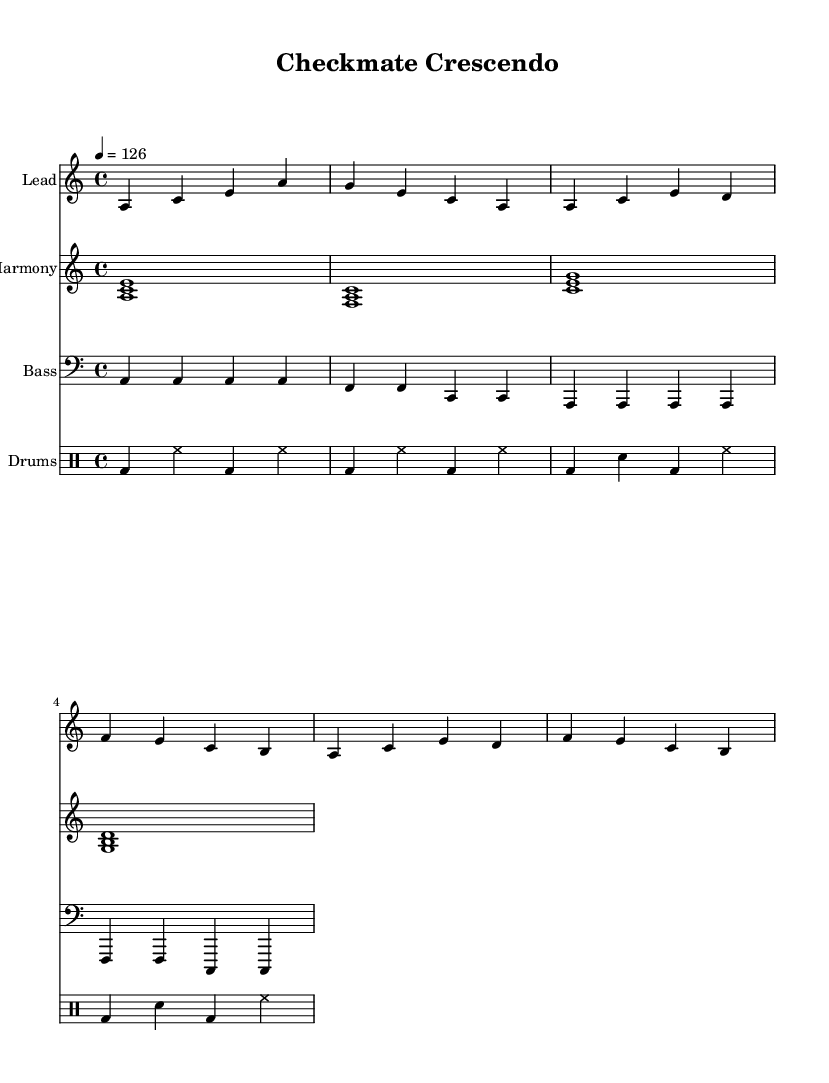What is the key signature of this music? The key signature is A minor, which has no sharps or flats.
Answer: A minor What is the time signature used in the piece? The time signature is indicated as 4/4, which means there are four beats in a measure with a quarter note getting one beat.
Answer: 4/4 What is the tempo marking for this piece? The tempo marking indicates a speed of 126 beats per minute, which is noted in the score.
Answer: 126 How many measures are in the main theme? The main theme consists of two measures that are repeated, resulting in a total of four measures for the repeated theme.
Answer: 4 What is the note that starts the melody? The note that starts the melody is A, which is the first note of the introductory section.
Answer: A How many different instruments are used in the score? The score features four distinct instruments: Lead, Harmony, Bass, and Drums, each represented in the notation.
Answer: 4 What type of rhythmic pattern is primarily used in the drum section? The drum section employs a basic kick drum and hi-hat pattern, typical of House music, providing a driving rhythmic foundation.
Answer: Kick and hi-hat 